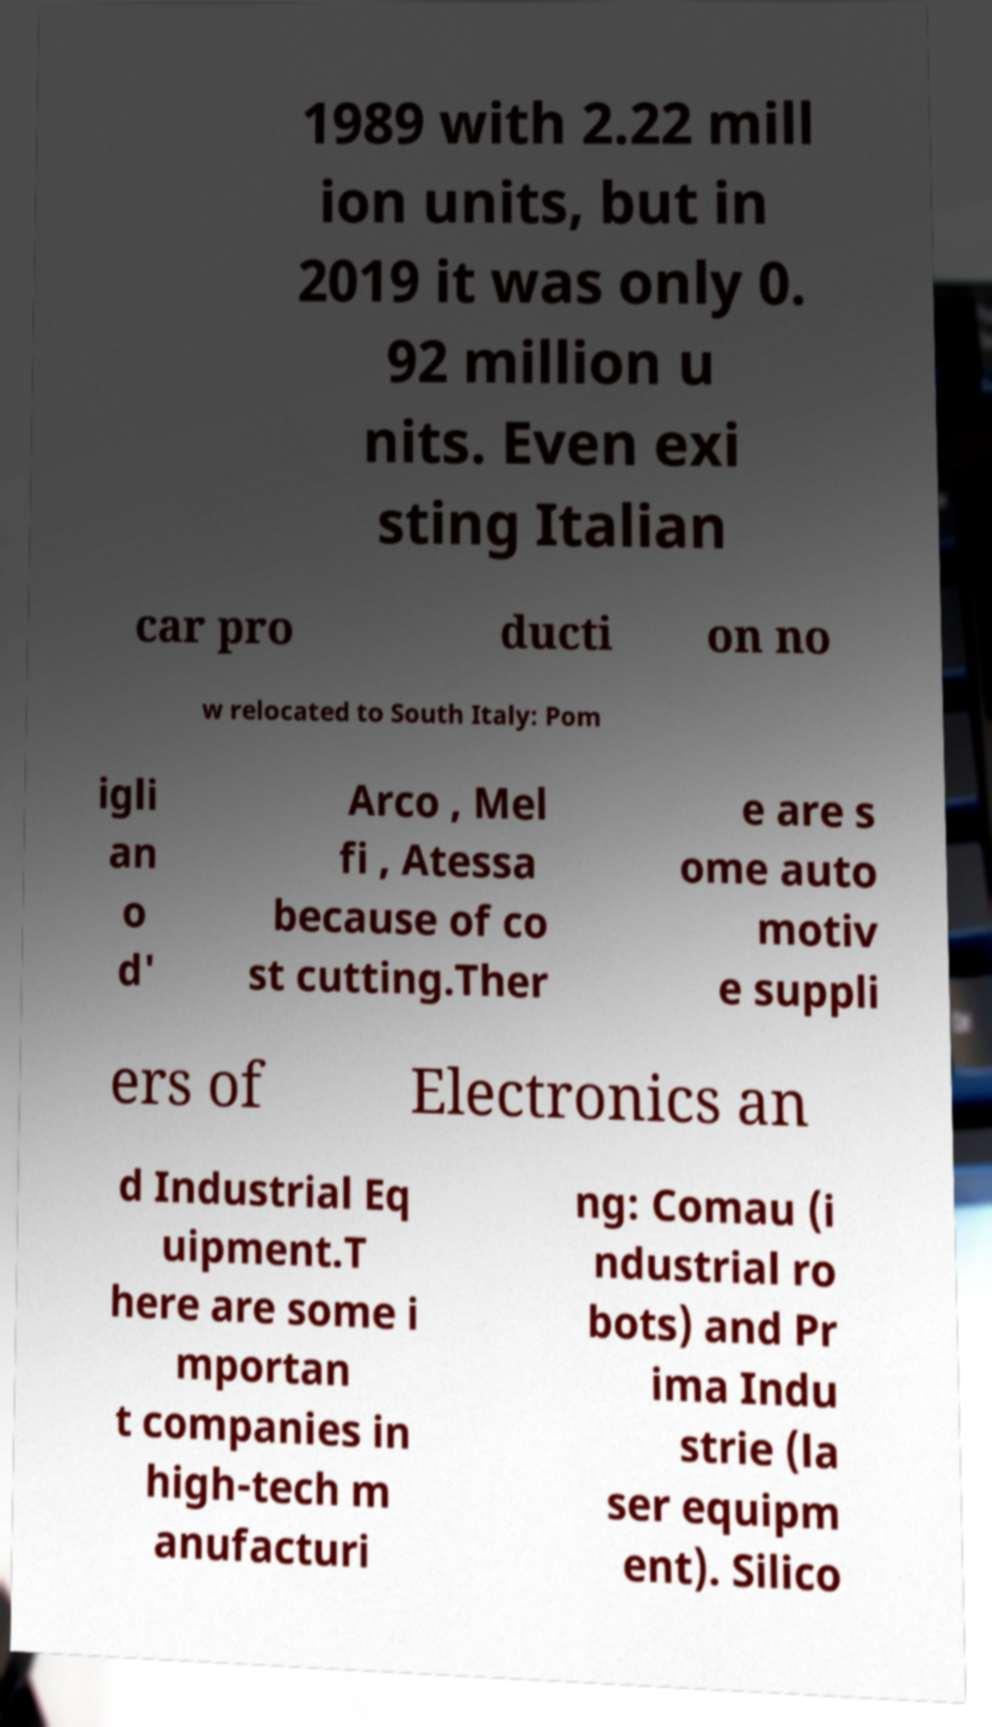Could you extract and type out the text from this image? 1989 with 2.22 mill ion units, but in 2019 it was only 0. 92 million u nits. Even exi sting Italian car pro ducti on no w relocated to South Italy: Pom igli an o d' Arco , Mel fi , Atessa because of co st cutting.Ther e are s ome auto motiv e suppli ers of Electronics an d Industrial Eq uipment.T here are some i mportan t companies in high-tech m anufacturi ng: Comau (i ndustrial ro bots) and Pr ima Indu strie (la ser equipm ent). Silico 